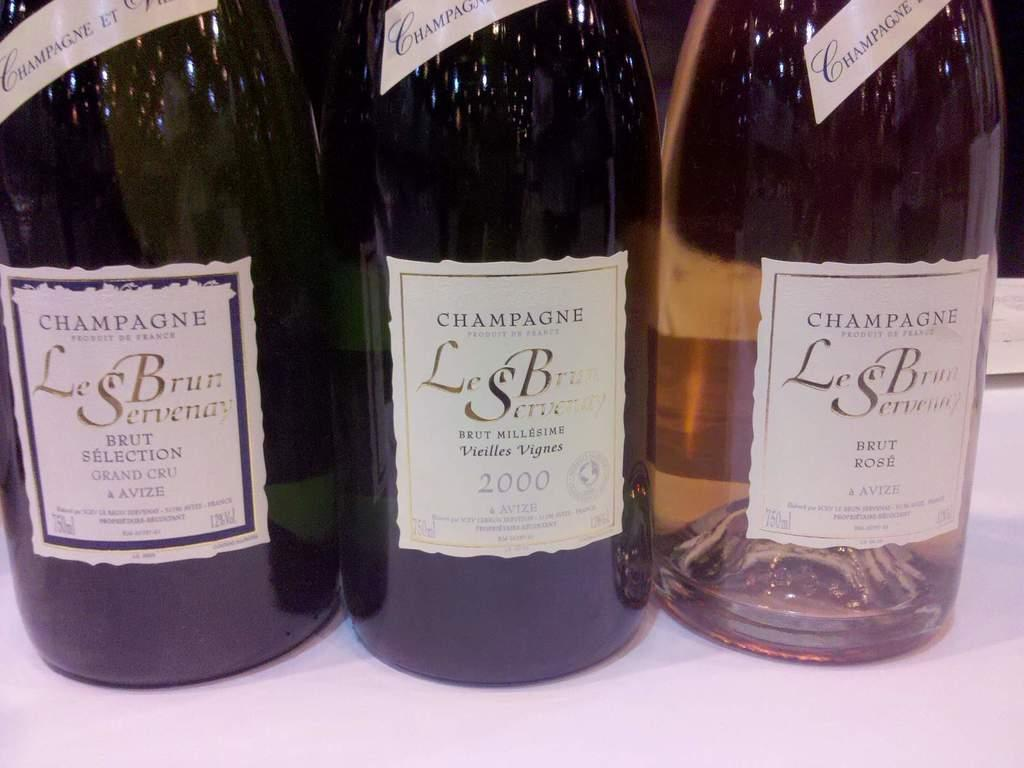<image>
Share a concise interpretation of the image provided. A bottle in between two others has the year 2000 on the label. 